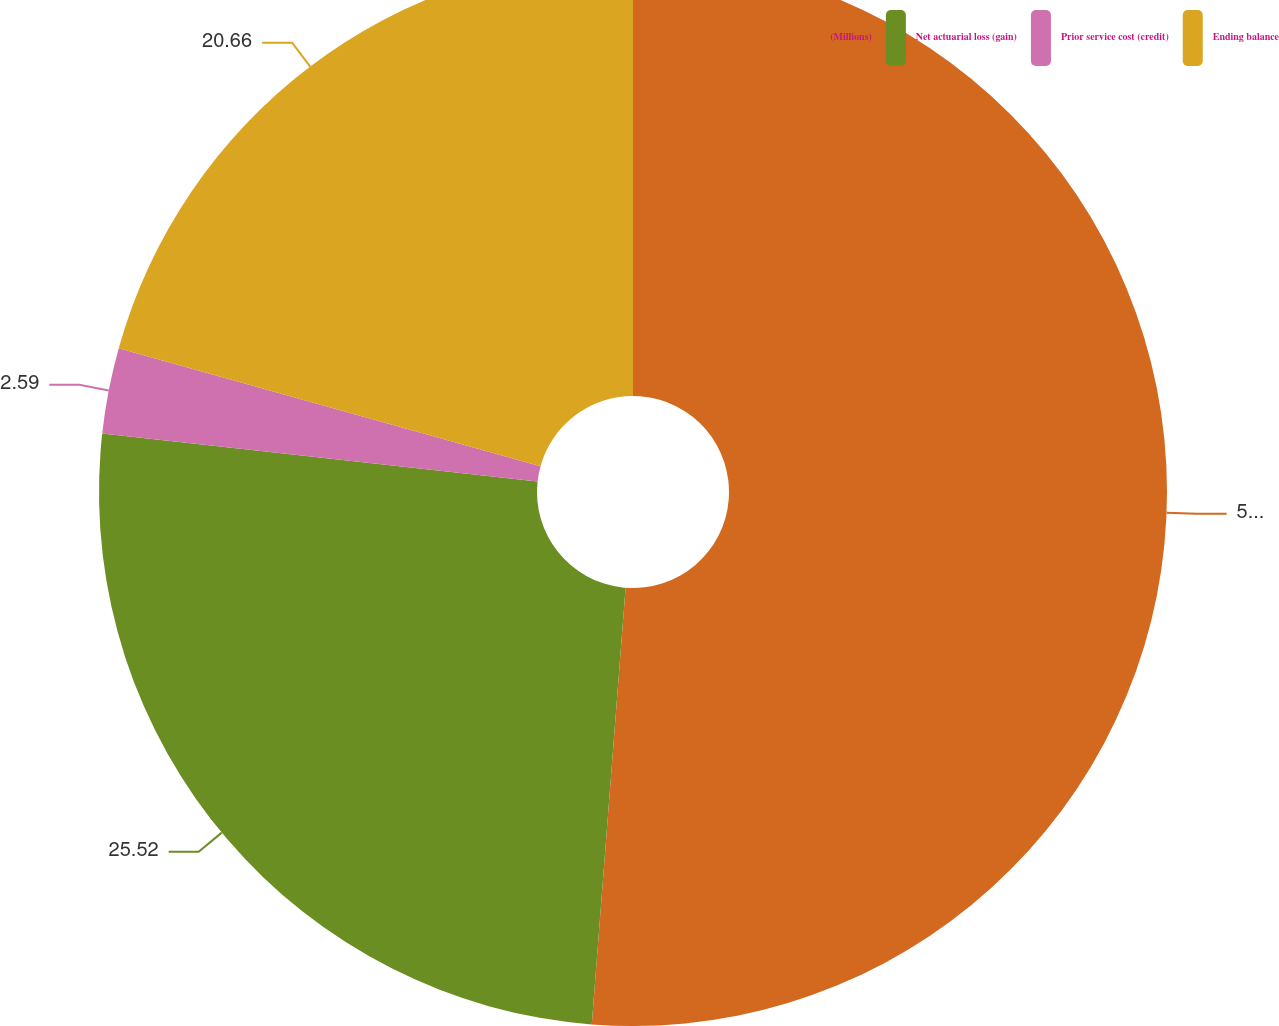<chart> <loc_0><loc_0><loc_500><loc_500><pie_chart><fcel>(Millions)<fcel>Net actuarial loss (gain)<fcel>Prior service cost (credit)<fcel>Ending balance<nl><fcel>51.23%<fcel>25.52%<fcel>2.59%<fcel>20.66%<nl></chart> 